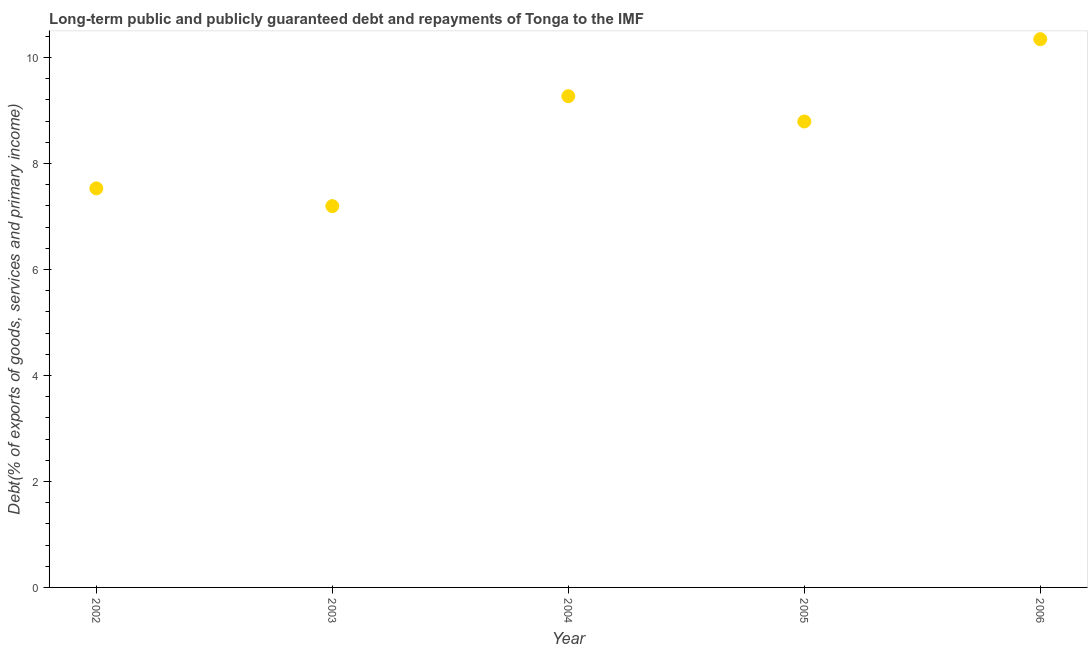What is the debt service in 2004?
Ensure brevity in your answer.  9.27. Across all years, what is the maximum debt service?
Offer a very short reply. 10.35. Across all years, what is the minimum debt service?
Provide a short and direct response. 7.2. In which year was the debt service maximum?
Give a very brief answer. 2006. What is the sum of the debt service?
Provide a succinct answer. 43.14. What is the difference between the debt service in 2003 and 2004?
Make the answer very short. -2.07. What is the average debt service per year?
Give a very brief answer. 8.63. What is the median debt service?
Keep it short and to the point. 8.79. In how many years, is the debt service greater than 7.2 %?
Make the answer very short. 4. What is the ratio of the debt service in 2005 to that in 2006?
Provide a short and direct response. 0.85. What is the difference between the highest and the second highest debt service?
Offer a terse response. 1.08. Is the sum of the debt service in 2004 and 2006 greater than the maximum debt service across all years?
Provide a short and direct response. Yes. What is the difference between the highest and the lowest debt service?
Offer a very short reply. 3.15. In how many years, is the debt service greater than the average debt service taken over all years?
Your response must be concise. 3. How many dotlines are there?
Offer a terse response. 1. How many years are there in the graph?
Make the answer very short. 5. Are the values on the major ticks of Y-axis written in scientific E-notation?
Give a very brief answer. No. Does the graph contain any zero values?
Make the answer very short. No. Does the graph contain grids?
Provide a short and direct response. No. What is the title of the graph?
Provide a succinct answer. Long-term public and publicly guaranteed debt and repayments of Tonga to the IMF. What is the label or title of the Y-axis?
Your answer should be compact. Debt(% of exports of goods, services and primary income). What is the Debt(% of exports of goods, services and primary income) in 2002?
Give a very brief answer. 7.53. What is the Debt(% of exports of goods, services and primary income) in 2003?
Give a very brief answer. 7.2. What is the Debt(% of exports of goods, services and primary income) in 2004?
Provide a succinct answer. 9.27. What is the Debt(% of exports of goods, services and primary income) in 2005?
Your response must be concise. 8.79. What is the Debt(% of exports of goods, services and primary income) in 2006?
Your answer should be very brief. 10.35. What is the difference between the Debt(% of exports of goods, services and primary income) in 2002 and 2003?
Give a very brief answer. 0.33. What is the difference between the Debt(% of exports of goods, services and primary income) in 2002 and 2004?
Ensure brevity in your answer.  -1.74. What is the difference between the Debt(% of exports of goods, services and primary income) in 2002 and 2005?
Your answer should be very brief. -1.26. What is the difference between the Debt(% of exports of goods, services and primary income) in 2002 and 2006?
Give a very brief answer. -2.82. What is the difference between the Debt(% of exports of goods, services and primary income) in 2003 and 2004?
Provide a succinct answer. -2.07. What is the difference between the Debt(% of exports of goods, services and primary income) in 2003 and 2005?
Give a very brief answer. -1.6. What is the difference between the Debt(% of exports of goods, services and primary income) in 2003 and 2006?
Your answer should be compact. -3.15. What is the difference between the Debt(% of exports of goods, services and primary income) in 2004 and 2005?
Keep it short and to the point. 0.48. What is the difference between the Debt(% of exports of goods, services and primary income) in 2004 and 2006?
Your answer should be very brief. -1.08. What is the difference between the Debt(% of exports of goods, services and primary income) in 2005 and 2006?
Your response must be concise. -1.55. What is the ratio of the Debt(% of exports of goods, services and primary income) in 2002 to that in 2003?
Keep it short and to the point. 1.05. What is the ratio of the Debt(% of exports of goods, services and primary income) in 2002 to that in 2004?
Your answer should be very brief. 0.81. What is the ratio of the Debt(% of exports of goods, services and primary income) in 2002 to that in 2005?
Provide a short and direct response. 0.86. What is the ratio of the Debt(% of exports of goods, services and primary income) in 2002 to that in 2006?
Provide a succinct answer. 0.73. What is the ratio of the Debt(% of exports of goods, services and primary income) in 2003 to that in 2004?
Provide a short and direct response. 0.78. What is the ratio of the Debt(% of exports of goods, services and primary income) in 2003 to that in 2005?
Provide a succinct answer. 0.82. What is the ratio of the Debt(% of exports of goods, services and primary income) in 2003 to that in 2006?
Make the answer very short. 0.7. What is the ratio of the Debt(% of exports of goods, services and primary income) in 2004 to that in 2005?
Give a very brief answer. 1.05. What is the ratio of the Debt(% of exports of goods, services and primary income) in 2004 to that in 2006?
Offer a terse response. 0.9. What is the ratio of the Debt(% of exports of goods, services and primary income) in 2005 to that in 2006?
Ensure brevity in your answer.  0.85. 